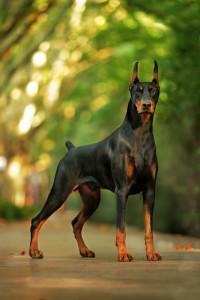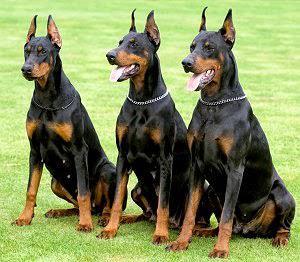The first image is the image on the left, the second image is the image on the right. For the images displayed, is the sentence "The right image contains at least two dogs." factually correct? Answer yes or no. Yes. 